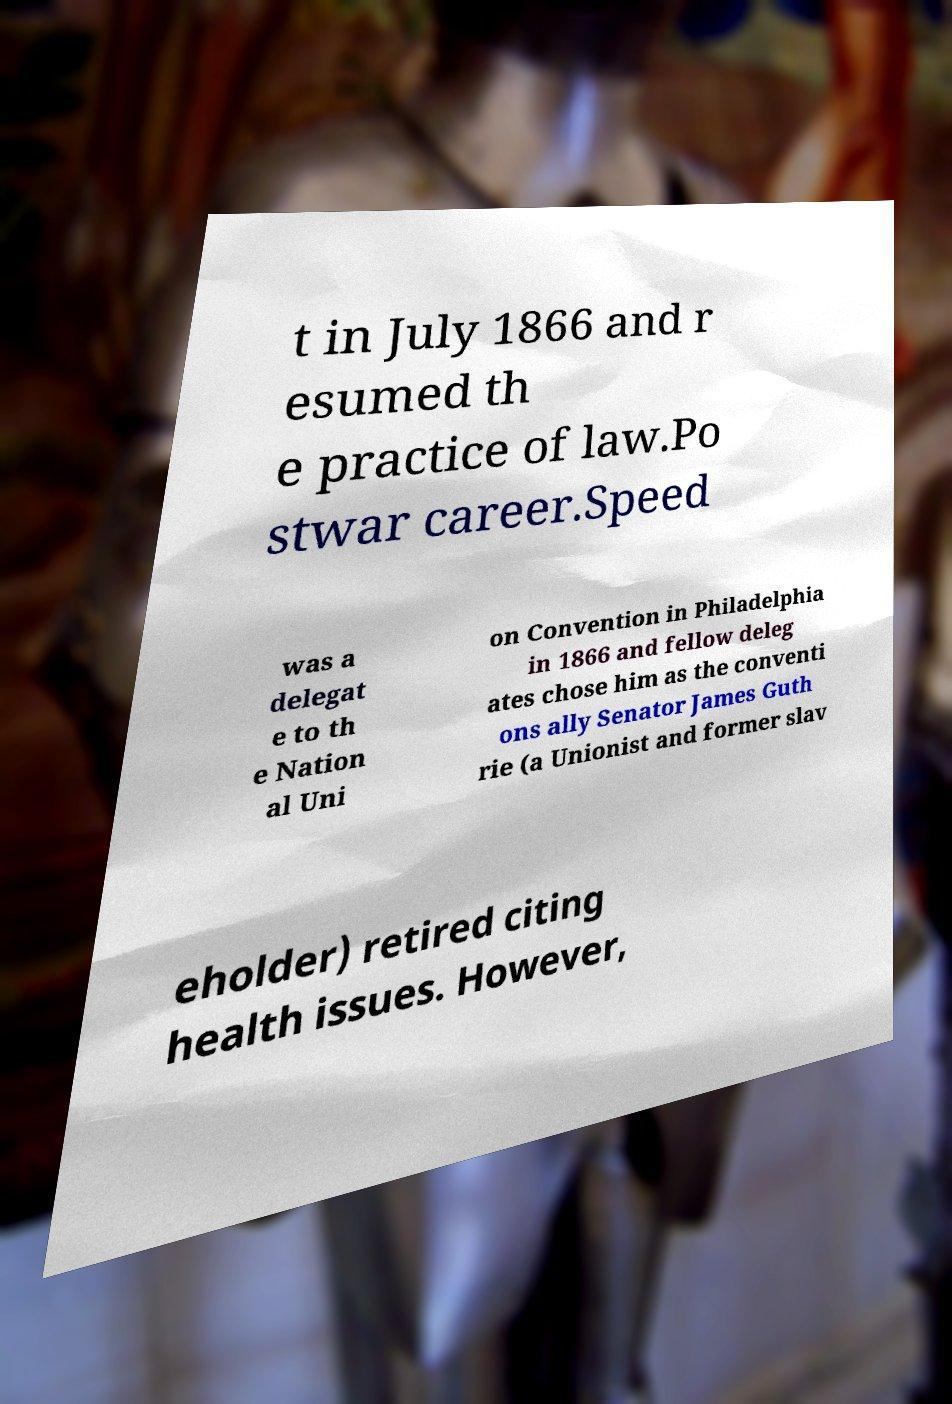For documentation purposes, I need the text within this image transcribed. Could you provide that? t in July 1866 and r esumed th e practice of law.Po stwar career.Speed was a delegat e to th e Nation al Uni on Convention in Philadelphia in 1866 and fellow deleg ates chose him as the conventi ons ally Senator James Guth rie (a Unionist and former slav eholder) retired citing health issues. However, 